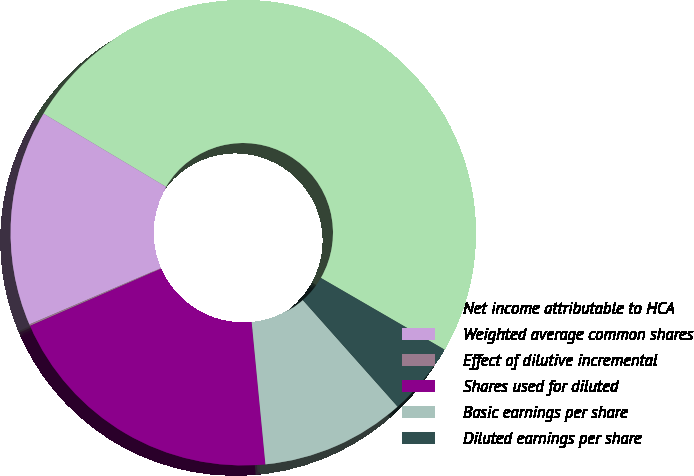<chart> <loc_0><loc_0><loc_500><loc_500><pie_chart><fcel>Net income attributable to HCA<fcel>Weighted average common shares<fcel>Effect of dilutive incremental<fcel>Shares used for diluted<fcel>Basic earnings per share<fcel>Diluted earnings per share<nl><fcel>49.79%<fcel>15.01%<fcel>0.11%<fcel>19.98%<fcel>10.04%<fcel>5.07%<nl></chart> 